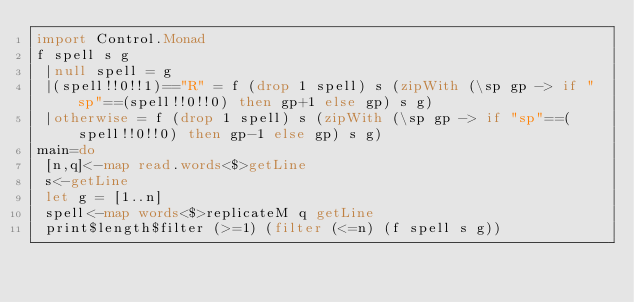<code> <loc_0><loc_0><loc_500><loc_500><_Haskell_>import Control.Monad
f spell s g
 |null spell = g
 |(spell!!0!!1)=="R" = f (drop 1 spell) s (zipWith (\sp gp -> if "sp"==(spell!!0!!0) then gp+1 else gp) s g)
 |otherwise = f (drop 1 spell) s (zipWith (\sp gp -> if "sp"==(spell!!0!!0) then gp-1 else gp) s g)
main=do
 [n,q]<-map read.words<$>getLine
 s<-getLine
 let g = [1..n]
 spell<-map words<$>replicateM q getLine
 print$length$filter (>=1) (filter (<=n) (f spell s g))
 
 </code> 